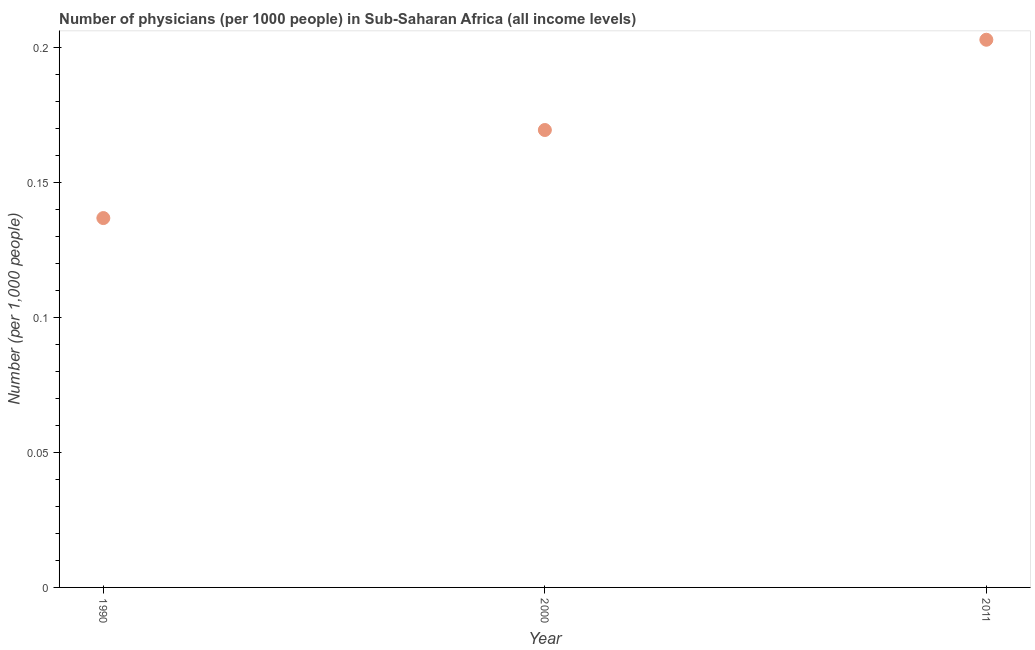What is the number of physicians in 2000?
Give a very brief answer. 0.17. Across all years, what is the maximum number of physicians?
Ensure brevity in your answer.  0.2. Across all years, what is the minimum number of physicians?
Offer a very short reply. 0.14. In which year was the number of physicians minimum?
Your answer should be compact. 1990. What is the sum of the number of physicians?
Provide a short and direct response. 0.51. What is the difference between the number of physicians in 1990 and 2011?
Your response must be concise. -0.07. What is the average number of physicians per year?
Offer a terse response. 0.17. What is the median number of physicians?
Offer a very short reply. 0.17. What is the ratio of the number of physicians in 1990 to that in 2011?
Offer a very short reply. 0.67. Is the number of physicians in 1990 less than that in 2011?
Offer a very short reply. Yes. What is the difference between the highest and the second highest number of physicians?
Offer a very short reply. 0.03. What is the difference between the highest and the lowest number of physicians?
Make the answer very short. 0.07. In how many years, is the number of physicians greater than the average number of physicians taken over all years?
Your response must be concise. 1. Does the number of physicians monotonically increase over the years?
Keep it short and to the point. Yes. How many dotlines are there?
Give a very brief answer. 1. What is the difference between two consecutive major ticks on the Y-axis?
Offer a terse response. 0.05. Are the values on the major ticks of Y-axis written in scientific E-notation?
Keep it short and to the point. No. Does the graph contain any zero values?
Keep it short and to the point. No. Does the graph contain grids?
Make the answer very short. No. What is the title of the graph?
Keep it short and to the point. Number of physicians (per 1000 people) in Sub-Saharan Africa (all income levels). What is the label or title of the Y-axis?
Provide a short and direct response. Number (per 1,0 people). What is the Number (per 1,000 people) in 1990?
Provide a succinct answer. 0.14. What is the Number (per 1,000 people) in 2000?
Provide a succinct answer. 0.17. What is the Number (per 1,000 people) in 2011?
Offer a terse response. 0.2. What is the difference between the Number (per 1,000 people) in 1990 and 2000?
Ensure brevity in your answer.  -0.03. What is the difference between the Number (per 1,000 people) in 1990 and 2011?
Your answer should be compact. -0.07. What is the difference between the Number (per 1,000 people) in 2000 and 2011?
Offer a terse response. -0.03. What is the ratio of the Number (per 1,000 people) in 1990 to that in 2000?
Give a very brief answer. 0.81. What is the ratio of the Number (per 1,000 people) in 1990 to that in 2011?
Your answer should be very brief. 0.67. What is the ratio of the Number (per 1,000 people) in 2000 to that in 2011?
Offer a very short reply. 0.83. 